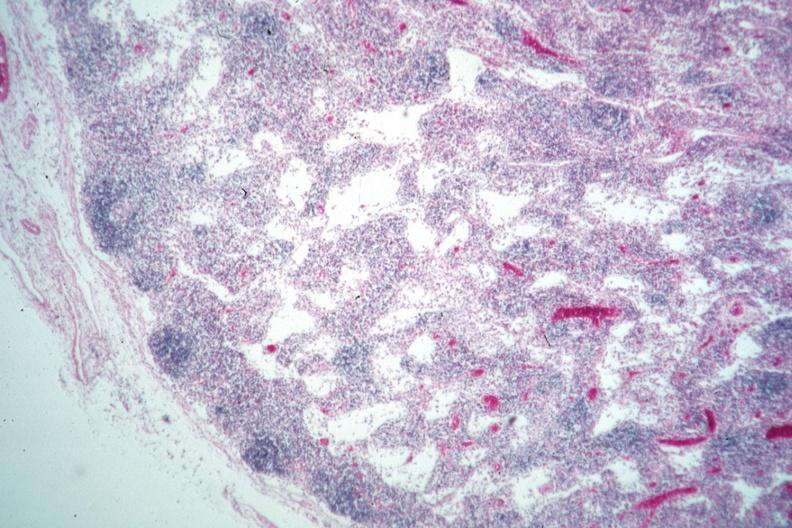s lymph node present?
Answer the question using a single word or phrase. Yes 